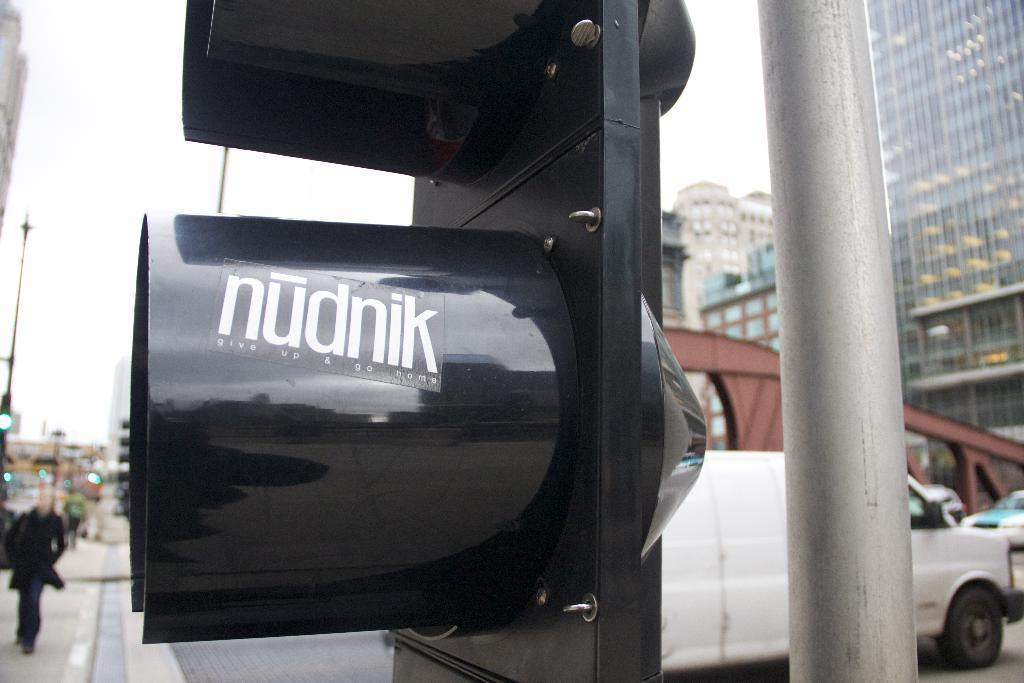Provide a one-sentence caption for the provided image. A sign on a downtown street with the name nudnik. 